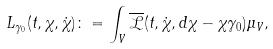<formula> <loc_0><loc_0><loc_500><loc_500>L _ { \gamma _ { 0 } } ( t , \chi , \dot { \chi } ) \colon = \int _ { V } \overline { \mathcal { L } } ( t , \dot { \chi } , d \chi - \chi \gamma _ { 0 } ) \mu _ { V } ,</formula> 